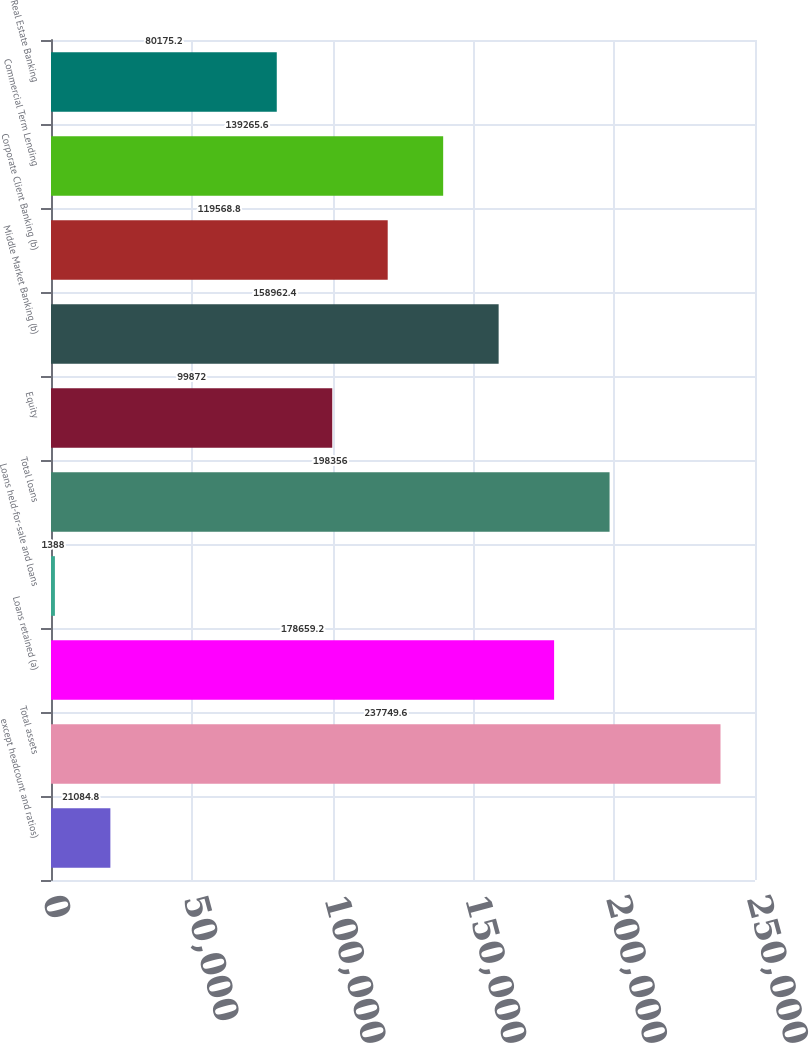<chart> <loc_0><loc_0><loc_500><loc_500><bar_chart><fcel>except headcount and ratios)<fcel>Total assets<fcel>Loans retained (a)<fcel>Loans held-for-sale and loans<fcel>Total loans<fcel>Equity<fcel>Middle Market Banking (b)<fcel>Corporate Client Banking (b)<fcel>Commercial Term Lending<fcel>Real Estate Banking<nl><fcel>21084.8<fcel>237750<fcel>178659<fcel>1388<fcel>198356<fcel>99872<fcel>158962<fcel>119569<fcel>139266<fcel>80175.2<nl></chart> 